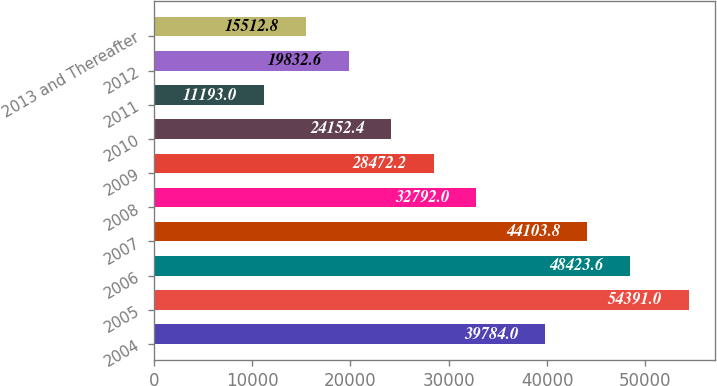Convert chart to OTSL. <chart><loc_0><loc_0><loc_500><loc_500><bar_chart><fcel>2004<fcel>2005<fcel>2006<fcel>2007<fcel>2008<fcel>2009<fcel>2010<fcel>2011<fcel>2012<fcel>2013 and Thereafter<nl><fcel>39784<fcel>54391<fcel>48423.6<fcel>44103.8<fcel>32792<fcel>28472.2<fcel>24152.4<fcel>11193<fcel>19832.6<fcel>15512.8<nl></chart> 